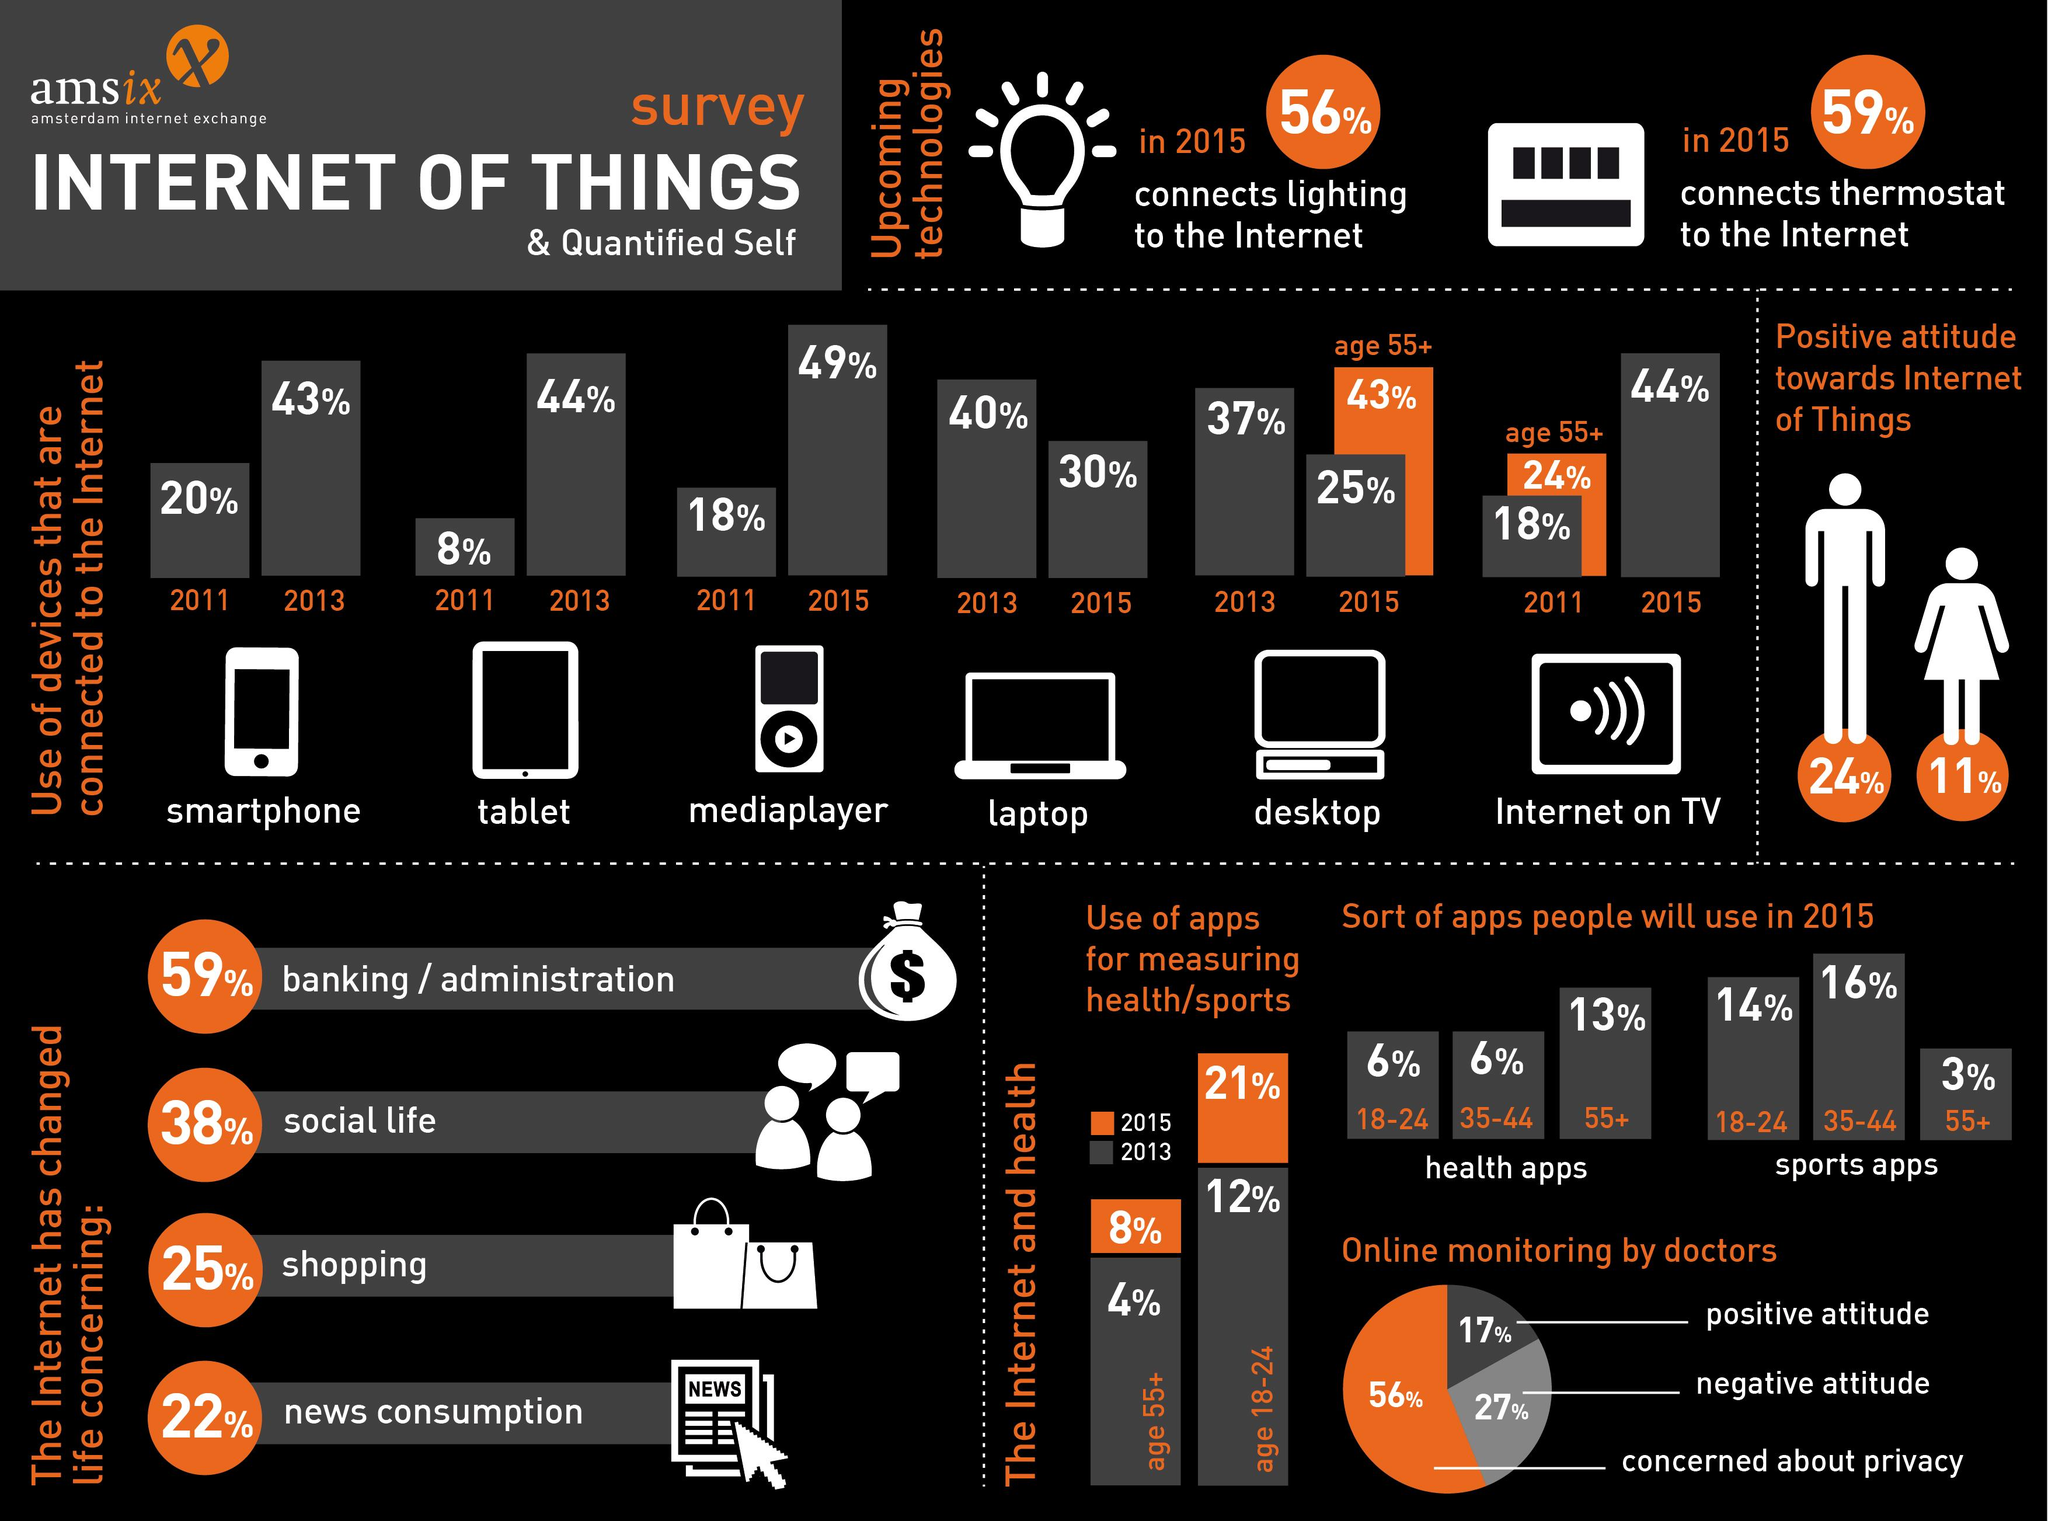Give some essential details in this illustration. According to a recent survey, 43% of people above the age of 55 use desktops that are connected to the internet. According to a recent survey, 21% of individuals between the ages of 18-24 years used health apps. According to the survey, only 8% of individuals over the age of 55 used health apps. The age group 35-44 was more likely to use sports apps than health or productivity apps. In the study, 35% of the participants who supported IoT were men, and 65% were women. 